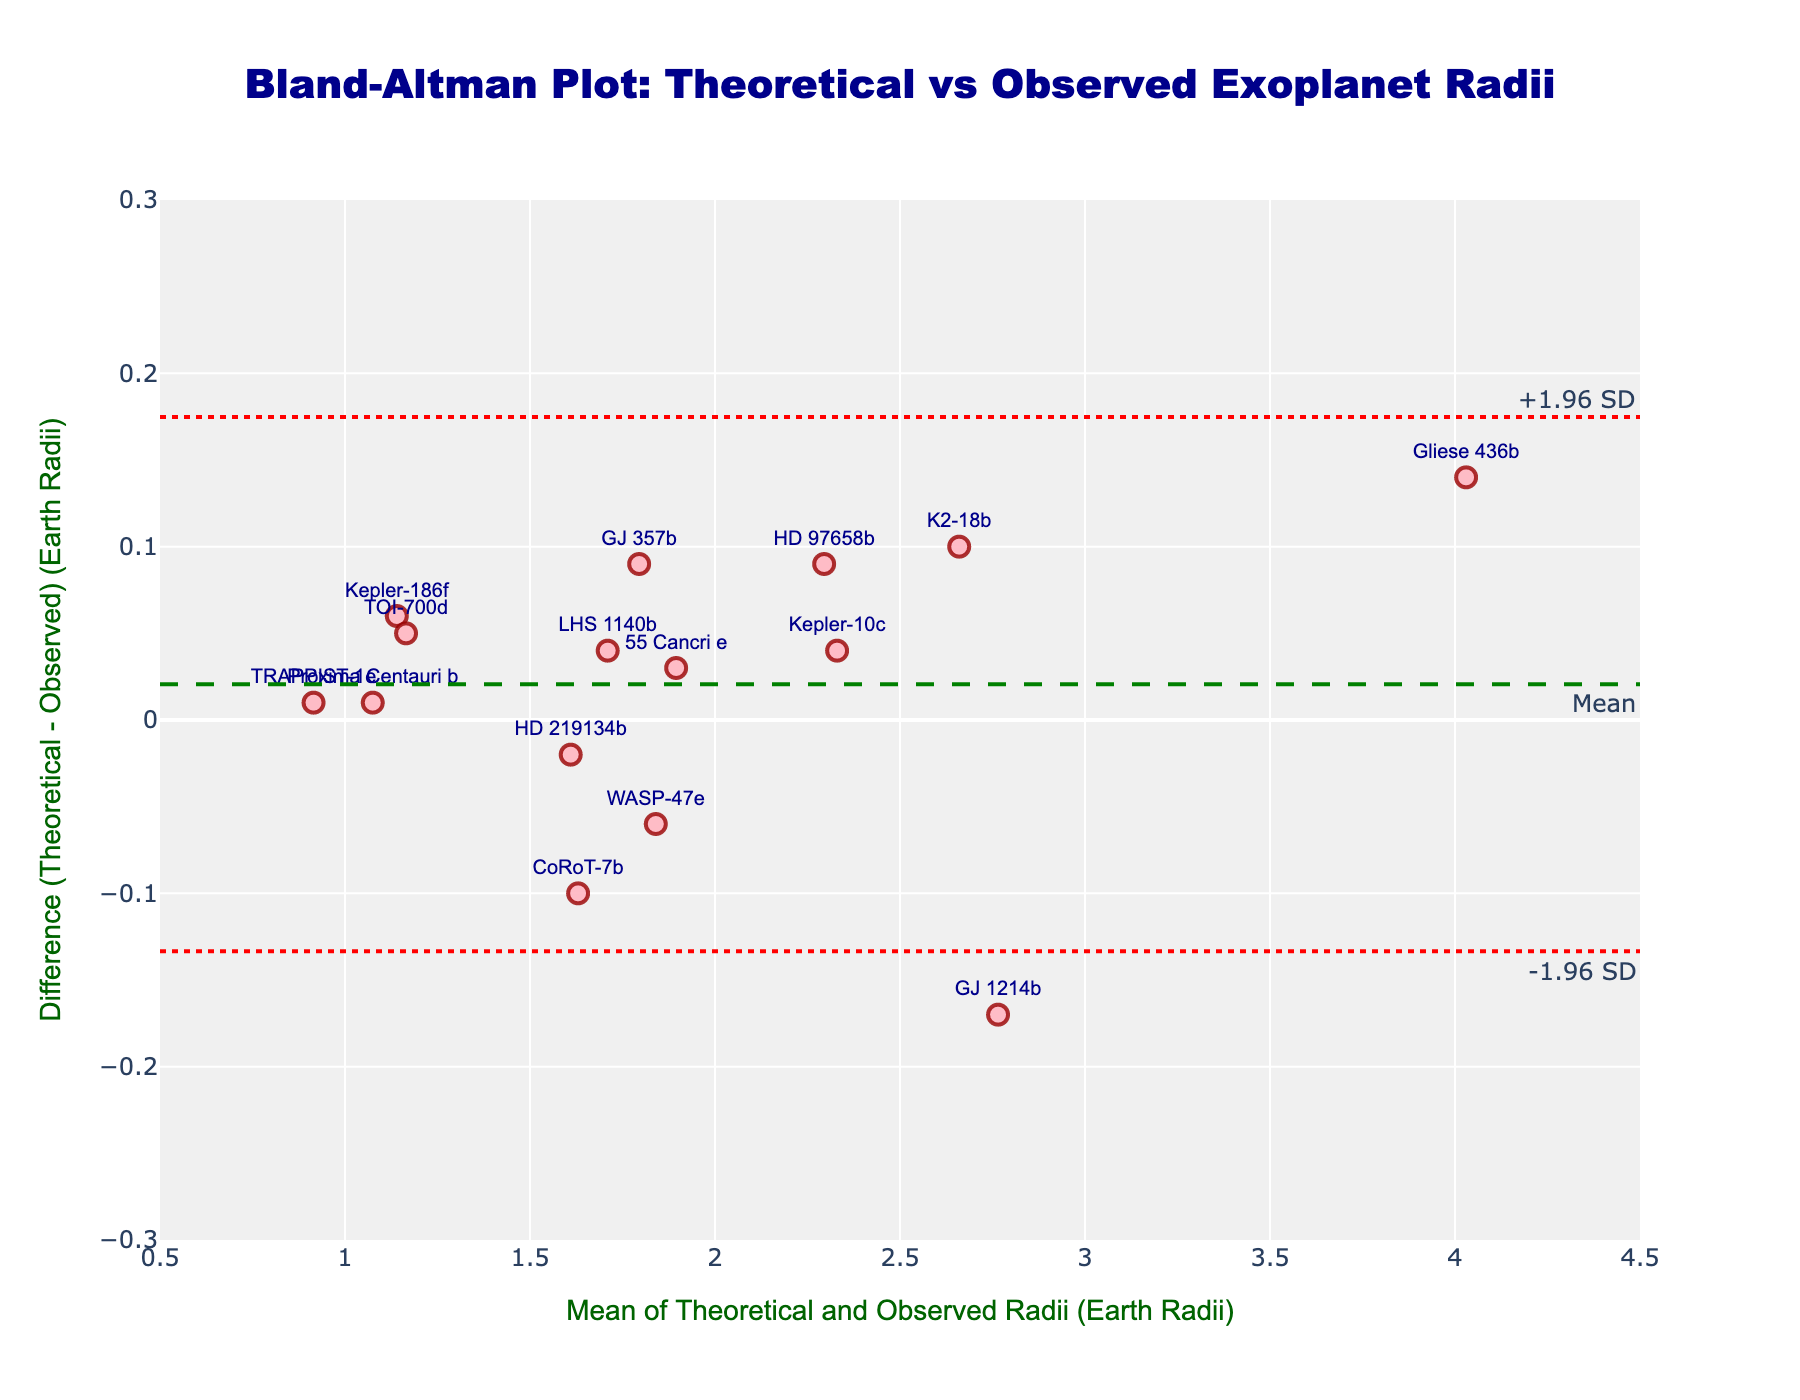What's the title of the figure? The title is located at the top of the plot and reads "Bland-Altman Plot: Theoretical vs Observed Exoplanet Radii."
Answer: Bland-Altman Plot: Theoretical vs Observed Exoplanet Radii What do the x-axis and y-axis represent in the plot? The x-axis title reads "Mean of Theoretical and Observed Radii (Earth Radii)" and the y-axis title reads "Difference (Theoretical - Observed) (Earth Radii)."
Answer: x-axis: Mean of Theoretical and Observed Radii (Earth Radii), y-axis: Difference (Theoretical - Observed) (Earth Radii) Which exoplanet has the largest positive difference between the theoretical and observed radii? The point located at the highest y-value in the positive direction is labelled "CoRoT-7b."
Answer: CoRoT-7b Are there more exoplanets with positive differences or negative differences between theoretical and observed radii? To determine this, count the points above and below the mean difference line. There are 6 points above the line (positive) and 9 points below the line (negative).
Answer: negative differences What are the values of the limits of agreement shown on the plot? The limits of agreement are marked by two dotted red lines with annotations showing "-1.96 SD" and "+1.96 SD." The y-values of these lines correspond to the annotations on the plot.
Answer: -0.2047 and 0.1885 Which exoplanet has a mean radius closest to 2 Earth radii? Locate the point near an x-value of 2 on the plot and identify the label. The closest point to the value of 2 is "HD 219134b."
Answer: HD 219134b What is the mean difference between theoretical and observed radii? The mean difference is represented by the dashed green line with an annotation reading "Mean."
Answer: 0.006 Is any exoplanet outside the limits of agreement? Check if any points fall outside the two red dotted lines marking the limits of agreement. No points are outside these limits.
Answer: No Between which x-axis values do most data points cluster? Observing the density of points on the x-axis, most points appear to cluster between the x-values of 1 and 2.
Answer: 1 and 2 Which exoplanets have a mean radius greater than 3 Earth radii? Identify points with an x-value greater than 3. These points are labeled "Gliese 436b."
Answer: Gliese 436b 